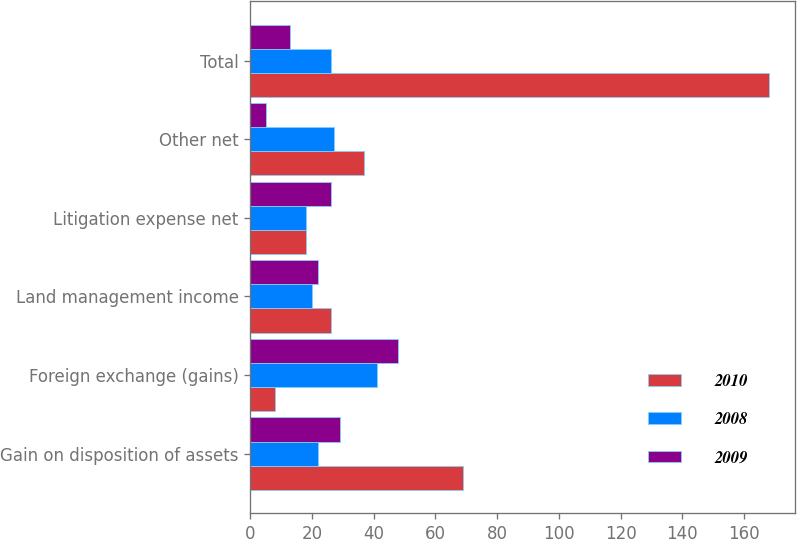<chart> <loc_0><loc_0><loc_500><loc_500><stacked_bar_chart><ecel><fcel>Gain on disposition of assets<fcel>Foreign exchange (gains)<fcel>Land management income<fcel>Litigation expense net<fcel>Other net<fcel>Total<nl><fcel>2010<fcel>69<fcel>8<fcel>26<fcel>18<fcel>37<fcel>168<nl><fcel>2008<fcel>22<fcel>41<fcel>20<fcel>18<fcel>27<fcel>26<nl><fcel>2009<fcel>29<fcel>48<fcel>22<fcel>26<fcel>5<fcel>13<nl></chart> 